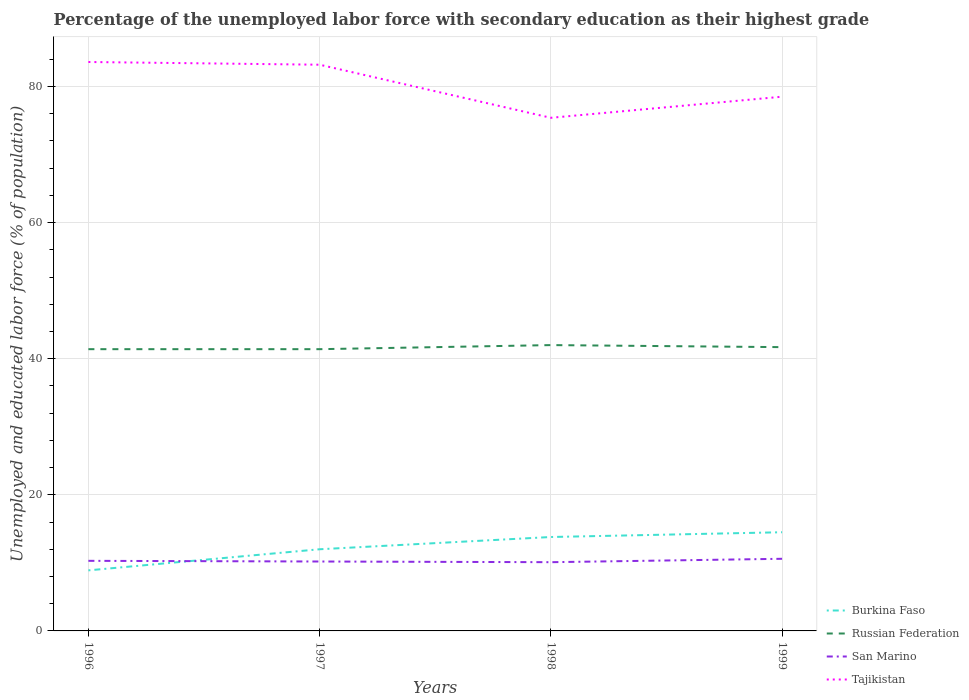Does the line corresponding to Tajikistan intersect with the line corresponding to Russian Federation?
Offer a terse response. No. Across all years, what is the maximum percentage of the unemployed labor force with secondary education in Tajikistan?
Your answer should be compact. 75.4. In which year was the percentage of the unemployed labor force with secondary education in San Marino maximum?
Your answer should be very brief. 1998. What is the total percentage of the unemployed labor force with secondary education in San Marino in the graph?
Provide a succinct answer. -0.3. What is the difference between the highest and the second highest percentage of the unemployed labor force with secondary education in Burkina Faso?
Provide a succinct answer. 5.6. How many lines are there?
Your answer should be very brief. 4. What is the difference between two consecutive major ticks on the Y-axis?
Ensure brevity in your answer.  20. Are the values on the major ticks of Y-axis written in scientific E-notation?
Make the answer very short. No. Does the graph contain any zero values?
Offer a very short reply. No. Does the graph contain grids?
Offer a very short reply. Yes. What is the title of the graph?
Make the answer very short. Percentage of the unemployed labor force with secondary education as their highest grade. Does "Mauritania" appear as one of the legend labels in the graph?
Offer a terse response. No. What is the label or title of the X-axis?
Offer a terse response. Years. What is the label or title of the Y-axis?
Your response must be concise. Unemployed and educated labor force (% of population). What is the Unemployed and educated labor force (% of population) in Burkina Faso in 1996?
Provide a short and direct response. 8.9. What is the Unemployed and educated labor force (% of population) in Russian Federation in 1996?
Your answer should be compact. 41.4. What is the Unemployed and educated labor force (% of population) in San Marino in 1996?
Offer a very short reply. 10.3. What is the Unemployed and educated labor force (% of population) of Tajikistan in 1996?
Keep it short and to the point. 83.6. What is the Unemployed and educated labor force (% of population) in Russian Federation in 1997?
Make the answer very short. 41.4. What is the Unemployed and educated labor force (% of population) in San Marino in 1997?
Offer a terse response. 10.2. What is the Unemployed and educated labor force (% of population) of Tajikistan in 1997?
Make the answer very short. 83.2. What is the Unemployed and educated labor force (% of population) of Burkina Faso in 1998?
Keep it short and to the point. 13.8. What is the Unemployed and educated labor force (% of population) of San Marino in 1998?
Your answer should be very brief. 10.1. What is the Unemployed and educated labor force (% of population) in Tajikistan in 1998?
Offer a terse response. 75.4. What is the Unemployed and educated labor force (% of population) of Burkina Faso in 1999?
Offer a terse response. 14.5. What is the Unemployed and educated labor force (% of population) of Russian Federation in 1999?
Provide a short and direct response. 41.7. What is the Unemployed and educated labor force (% of population) of San Marino in 1999?
Ensure brevity in your answer.  10.6. What is the Unemployed and educated labor force (% of population) of Tajikistan in 1999?
Provide a short and direct response. 78.5. Across all years, what is the maximum Unemployed and educated labor force (% of population) in San Marino?
Offer a terse response. 10.6. Across all years, what is the maximum Unemployed and educated labor force (% of population) in Tajikistan?
Keep it short and to the point. 83.6. Across all years, what is the minimum Unemployed and educated labor force (% of population) of Burkina Faso?
Ensure brevity in your answer.  8.9. Across all years, what is the minimum Unemployed and educated labor force (% of population) in Russian Federation?
Provide a succinct answer. 41.4. Across all years, what is the minimum Unemployed and educated labor force (% of population) of San Marino?
Your answer should be very brief. 10.1. Across all years, what is the minimum Unemployed and educated labor force (% of population) in Tajikistan?
Ensure brevity in your answer.  75.4. What is the total Unemployed and educated labor force (% of population) in Burkina Faso in the graph?
Give a very brief answer. 49.2. What is the total Unemployed and educated labor force (% of population) of Russian Federation in the graph?
Make the answer very short. 166.5. What is the total Unemployed and educated labor force (% of population) in San Marino in the graph?
Your answer should be very brief. 41.2. What is the total Unemployed and educated labor force (% of population) in Tajikistan in the graph?
Provide a short and direct response. 320.7. What is the difference between the Unemployed and educated labor force (% of population) of Burkina Faso in 1996 and that in 1997?
Make the answer very short. -3.1. What is the difference between the Unemployed and educated labor force (% of population) of Tajikistan in 1996 and that in 1998?
Ensure brevity in your answer.  8.2. What is the difference between the Unemployed and educated labor force (% of population) of Russian Federation in 1996 and that in 1999?
Provide a succinct answer. -0.3. What is the difference between the Unemployed and educated labor force (% of population) of Tajikistan in 1996 and that in 1999?
Make the answer very short. 5.1. What is the difference between the Unemployed and educated labor force (% of population) in Burkina Faso in 1997 and that in 1998?
Keep it short and to the point. -1.8. What is the difference between the Unemployed and educated labor force (% of population) in San Marino in 1997 and that in 1998?
Your answer should be very brief. 0.1. What is the difference between the Unemployed and educated labor force (% of population) of Tajikistan in 1997 and that in 1998?
Provide a short and direct response. 7.8. What is the difference between the Unemployed and educated labor force (% of population) of San Marino in 1997 and that in 1999?
Your response must be concise. -0.4. What is the difference between the Unemployed and educated labor force (% of population) of Tajikistan in 1998 and that in 1999?
Give a very brief answer. -3.1. What is the difference between the Unemployed and educated labor force (% of population) in Burkina Faso in 1996 and the Unemployed and educated labor force (% of population) in Russian Federation in 1997?
Ensure brevity in your answer.  -32.5. What is the difference between the Unemployed and educated labor force (% of population) of Burkina Faso in 1996 and the Unemployed and educated labor force (% of population) of Tajikistan in 1997?
Your answer should be very brief. -74.3. What is the difference between the Unemployed and educated labor force (% of population) in Russian Federation in 1996 and the Unemployed and educated labor force (% of population) in San Marino in 1997?
Provide a succinct answer. 31.2. What is the difference between the Unemployed and educated labor force (% of population) of Russian Federation in 1996 and the Unemployed and educated labor force (% of population) of Tajikistan in 1997?
Keep it short and to the point. -41.8. What is the difference between the Unemployed and educated labor force (% of population) of San Marino in 1996 and the Unemployed and educated labor force (% of population) of Tajikistan in 1997?
Provide a succinct answer. -72.9. What is the difference between the Unemployed and educated labor force (% of population) in Burkina Faso in 1996 and the Unemployed and educated labor force (% of population) in Russian Federation in 1998?
Ensure brevity in your answer.  -33.1. What is the difference between the Unemployed and educated labor force (% of population) in Burkina Faso in 1996 and the Unemployed and educated labor force (% of population) in San Marino in 1998?
Your answer should be compact. -1.2. What is the difference between the Unemployed and educated labor force (% of population) in Burkina Faso in 1996 and the Unemployed and educated labor force (% of population) in Tajikistan in 1998?
Your answer should be very brief. -66.5. What is the difference between the Unemployed and educated labor force (% of population) of Russian Federation in 1996 and the Unemployed and educated labor force (% of population) of San Marino in 1998?
Make the answer very short. 31.3. What is the difference between the Unemployed and educated labor force (% of population) of Russian Federation in 1996 and the Unemployed and educated labor force (% of population) of Tajikistan in 1998?
Make the answer very short. -34. What is the difference between the Unemployed and educated labor force (% of population) of San Marino in 1996 and the Unemployed and educated labor force (% of population) of Tajikistan in 1998?
Provide a short and direct response. -65.1. What is the difference between the Unemployed and educated labor force (% of population) in Burkina Faso in 1996 and the Unemployed and educated labor force (% of population) in Russian Federation in 1999?
Make the answer very short. -32.8. What is the difference between the Unemployed and educated labor force (% of population) in Burkina Faso in 1996 and the Unemployed and educated labor force (% of population) in San Marino in 1999?
Your answer should be compact. -1.7. What is the difference between the Unemployed and educated labor force (% of population) in Burkina Faso in 1996 and the Unemployed and educated labor force (% of population) in Tajikistan in 1999?
Your response must be concise. -69.6. What is the difference between the Unemployed and educated labor force (% of population) in Russian Federation in 1996 and the Unemployed and educated labor force (% of population) in San Marino in 1999?
Ensure brevity in your answer.  30.8. What is the difference between the Unemployed and educated labor force (% of population) in Russian Federation in 1996 and the Unemployed and educated labor force (% of population) in Tajikistan in 1999?
Offer a very short reply. -37.1. What is the difference between the Unemployed and educated labor force (% of population) of San Marino in 1996 and the Unemployed and educated labor force (% of population) of Tajikistan in 1999?
Make the answer very short. -68.2. What is the difference between the Unemployed and educated labor force (% of population) in Burkina Faso in 1997 and the Unemployed and educated labor force (% of population) in San Marino in 1998?
Provide a succinct answer. 1.9. What is the difference between the Unemployed and educated labor force (% of population) in Burkina Faso in 1997 and the Unemployed and educated labor force (% of population) in Tajikistan in 1998?
Your response must be concise. -63.4. What is the difference between the Unemployed and educated labor force (% of population) in Russian Federation in 1997 and the Unemployed and educated labor force (% of population) in San Marino in 1998?
Keep it short and to the point. 31.3. What is the difference between the Unemployed and educated labor force (% of population) in Russian Federation in 1997 and the Unemployed and educated labor force (% of population) in Tajikistan in 1998?
Ensure brevity in your answer.  -34. What is the difference between the Unemployed and educated labor force (% of population) of San Marino in 1997 and the Unemployed and educated labor force (% of population) of Tajikistan in 1998?
Your answer should be very brief. -65.2. What is the difference between the Unemployed and educated labor force (% of population) in Burkina Faso in 1997 and the Unemployed and educated labor force (% of population) in Russian Federation in 1999?
Your response must be concise. -29.7. What is the difference between the Unemployed and educated labor force (% of population) in Burkina Faso in 1997 and the Unemployed and educated labor force (% of population) in San Marino in 1999?
Offer a very short reply. 1.4. What is the difference between the Unemployed and educated labor force (% of population) in Burkina Faso in 1997 and the Unemployed and educated labor force (% of population) in Tajikistan in 1999?
Provide a short and direct response. -66.5. What is the difference between the Unemployed and educated labor force (% of population) of Russian Federation in 1997 and the Unemployed and educated labor force (% of population) of San Marino in 1999?
Keep it short and to the point. 30.8. What is the difference between the Unemployed and educated labor force (% of population) in Russian Federation in 1997 and the Unemployed and educated labor force (% of population) in Tajikistan in 1999?
Provide a short and direct response. -37.1. What is the difference between the Unemployed and educated labor force (% of population) in San Marino in 1997 and the Unemployed and educated labor force (% of population) in Tajikistan in 1999?
Give a very brief answer. -68.3. What is the difference between the Unemployed and educated labor force (% of population) in Burkina Faso in 1998 and the Unemployed and educated labor force (% of population) in Russian Federation in 1999?
Offer a terse response. -27.9. What is the difference between the Unemployed and educated labor force (% of population) in Burkina Faso in 1998 and the Unemployed and educated labor force (% of population) in Tajikistan in 1999?
Make the answer very short. -64.7. What is the difference between the Unemployed and educated labor force (% of population) of Russian Federation in 1998 and the Unemployed and educated labor force (% of population) of San Marino in 1999?
Offer a very short reply. 31.4. What is the difference between the Unemployed and educated labor force (% of population) in Russian Federation in 1998 and the Unemployed and educated labor force (% of population) in Tajikistan in 1999?
Make the answer very short. -36.5. What is the difference between the Unemployed and educated labor force (% of population) in San Marino in 1998 and the Unemployed and educated labor force (% of population) in Tajikistan in 1999?
Keep it short and to the point. -68.4. What is the average Unemployed and educated labor force (% of population) of Russian Federation per year?
Provide a succinct answer. 41.62. What is the average Unemployed and educated labor force (% of population) of Tajikistan per year?
Provide a succinct answer. 80.17. In the year 1996, what is the difference between the Unemployed and educated labor force (% of population) in Burkina Faso and Unemployed and educated labor force (% of population) in Russian Federation?
Ensure brevity in your answer.  -32.5. In the year 1996, what is the difference between the Unemployed and educated labor force (% of population) of Burkina Faso and Unemployed and educated labor force (% of population) of Tajikistan?
Offer a very short reply. -74.7. In the year 1996, what is the difference between the Unemployed and educated labor force (% of population) in Russian Federation and Unemployed and educated labor force (% of population) in San Marino?
Offer a very short reply. 31.1. In the year 1996, what is the difference between the Unemployed and educated labor force (% of population) of Russian Federation and Unemployed and educated labor force (% of population) of Tajikistan?
Ensure brevity in your answer.  -42.2. In the year 1996, what is the difference between the Unemployed and educated labor force (% of population) in San Marino and Unemployed and educated labor force (% of population) in Tajikistan?
Your response must be concise. -73.3. In the year 1997, what is the difference between the Unemployed and educated labor force (% of population) of Burkina Faso and Unemployed and educated labor force (% of population) of Russian Federation?
Your answer should be very brief. -29.4. In the year 1997, what is the difference between the Unemployed and educated labor force (% of population) in Burkina Faso and Unemployed and educated labor force (% of population) in Tajikistan?
Provide a succinct answer. -71.2. In the year 1997, what is the difference between the Unemployed and educated labor force (% of population) in Russian Federation and Unemployed and educated labor force (% of population) in San Marino?
Give a very brief answer. 31.2. In the year 1997, what is the difference between the Unemployed and educated labor force (% of population) in Russian Federation and Unemployed and educated labor force (% of population) in Tajikistan?
Ensure brevity in your answer.  -41.8. In the year 1997, what is the difference between the Unemployed and educated labor force (% of population) of San Marino and Unemployed and educated labor force (% of population) of Tajikistan?
Provide a short and direct response. -73. In the year 1998, what is the difference between the Unemployed and educated labor force (% of population) of Burkina Faso and Unemployed and educated labor force (% of population) of Russian Federation?
Offer a very short reply. -28.2. In the year 1998, what is the difference between the Unemployed and educated labor force (% of population) of Burkina Faso and Unemployed and educated labor force (% of population) of San Marino?
Your answer should be compact. 3.7. In the year 1998, what is the difference between the Unemployed and educated labor force (% of population) in Burkina Faso and Unemployed and educated labor force (% of population) in Tajikistan?
Provide a succinct answer. -61.6. In the year 1998, what is the difference between the Unemployed and educated labor force (% of population) of Russian Federation and Unemployed and educated labor force (% of population) of San Marino?
Offer a terse response. 31.9. In the year 1998, what is the difference between the Unemployed and educated labor force (% of population) in Russian Federation and Unemployed and educated labor force (% of population) in Tajikistan?
Keep it short and to the point. -33.4. In the year 1998, what is the difference between the Unemployed and educated labor force (% of population) in San Marino and Unemployed and educated labor force (% of population) in Tajikistan?
Your response must be concise. -65.3. In the year 1999, what is the difference between the Unemployed and educated labor force (% of population) in Burkina Faso and Unemployed and educated labor force (% of population) in Russian Federation?
Ensure brevity in your answer.  -27.2. In the year 1999, what is the difference between the Unemployed and educated labor force (% of population) in Burkina Faso and Unemployed and educated labor force (% of population) in San Marino?
Offer a very short reply. 3.9. In the year 1999, what is the difference between the Unemployed and educated labor force (% of population) in Burkina Faso and Unemployed and educated labor force (% of population) in Tajikistan?
Offer a very short reply. -64. In the year 1999, what is the difference between the Unemployed and educated labor force (% of population) in Russian Federation and Unemployed and educated labor force (% of population) in San Marino?
Your response must be concise. 31.1. In the year 1999, what is the difference between the Unemployed and educated labor force (% of population) in Russian Federation and Unemployed and educated labor force (% of population) in Tajikistan?
Provide a short and direct response. -36.8. In the year 1999, what is the difference between the Unemployed and educated labor force (% of population) in San Marino and Unemployed and educated labor force (% of population) in Tajikistan?
Provide a short and direct response. -67.9. What is the ratio of the Unemployed and educated labor force (% of population) of Burkina Faso in 1996 to that in 1997?
Ensure brevity in your answer.  0.74. What is the ratio of the Unemployed and educated labor force (% of population) of San Marino in 1996 to that in 1997?
Provide a succinct answer. 1.01. What is the ratio of the Unemployed and educated labor force (% of population) in Tajikistan in 1996 to that in 1997?
Make the answer very short. 1. What is the ratio of the Unemployed and educated labor force (% of population) in Burkina Faso in 1996 to that in 1998?
Provide a succinct answer. 0.64. What is the ratio of the Unemployed and educated labor force (% of population) in Russian Federation in 1996 to that in 1998?
Offer a very short reply. 0.99. What is the ratio of the Unemployed and educated labor force (% of population) of San Marino in 1996 to that in 1998?
Your response must be concise. 1.02. What is the ratio of the Unemployed and educated labor force (% of population) of Tajikistan in 1996 to that in 1998?
Your answer should be compact. 1.11. What is the ratio of the Unemployed and educated labor force (% of population) of Burkina Faso in 1996 to that in 1999?
Give a very brief answer. 0.61. What is the ratio of the Unemployed and educated labor force (% of population) in San Marino in 1996 to that in 1999?
Your answer should be very brief. 0.97. What is the ratio of the Unemployed and educated labor force (% of population) in Tajikistan in 1996 to that in 1999?
Make the answer very short. 1.06. What is the ratio of the Unemployed and educated labor force (% of population) in Burkina Faso in 1997 to that in 1998?
Give a very brief answer. 0.87. What is the ratio of the Unemployed and educated labor force (% of population) of Russian Federation in 1997 to that in 1998?
Ensure brevity in your answer.  0.99. What is the ratio of the Unemployed and educated labor force (% of population) in San Marino in 1997 to that in 1998?
Your response must be concise. 1.01. What is the ratio of the Unemployed and educated labor force (% of population) in Tajikistan in 1997 to that in 1998?
Provide a short and direct response. 1.1. What is the ratio of the Unemployed and educated labor force (% of population) in Burkina Faso in 1997 to that in 1999?
Offer a very short reply. 0.83. What is the ratio of the Unemployed and educated labor force (% of population) in Russian Federation in 1997 to that in 1999?
Your answer should be compact. 0.99. What is the ratio of the Unemployed and educated labor force (% of population) of San Marino in 1997 to that in 1999?
Give a very brief answer. 0.96. What is the ratio of the Unemployed and educated labor force (% of population) in Tajikistan in 1997 to that in 1999?
Your answer should be very brief. 1.06. What is the ratio of the Unemployed and educated labor force (% of population) in Burkina Faso in 1998 to that in 1999?
Ensure brevity in your answer.  0.95. What is the ratio of the Unemployed and educated labor force (% of population) of San Marino in 1998 to that in 1999?
Offer a very short reply. 0.95. What is the ratio of the Unemployed and educated labor force (% of population) of Tajikistan in 1998 to that in 1999?
Offer a very short reply. 0.96. What is the difference between the highest and the lowest Unemployed and educated labor force (% of population) in Russian Federation?
Provide a short and direct response. 0.6. What is the difference between the highest and the lowest Unemployed and educated labor force (% of population) in San Marino?
Ensure brevity in your answer.  0.5. 